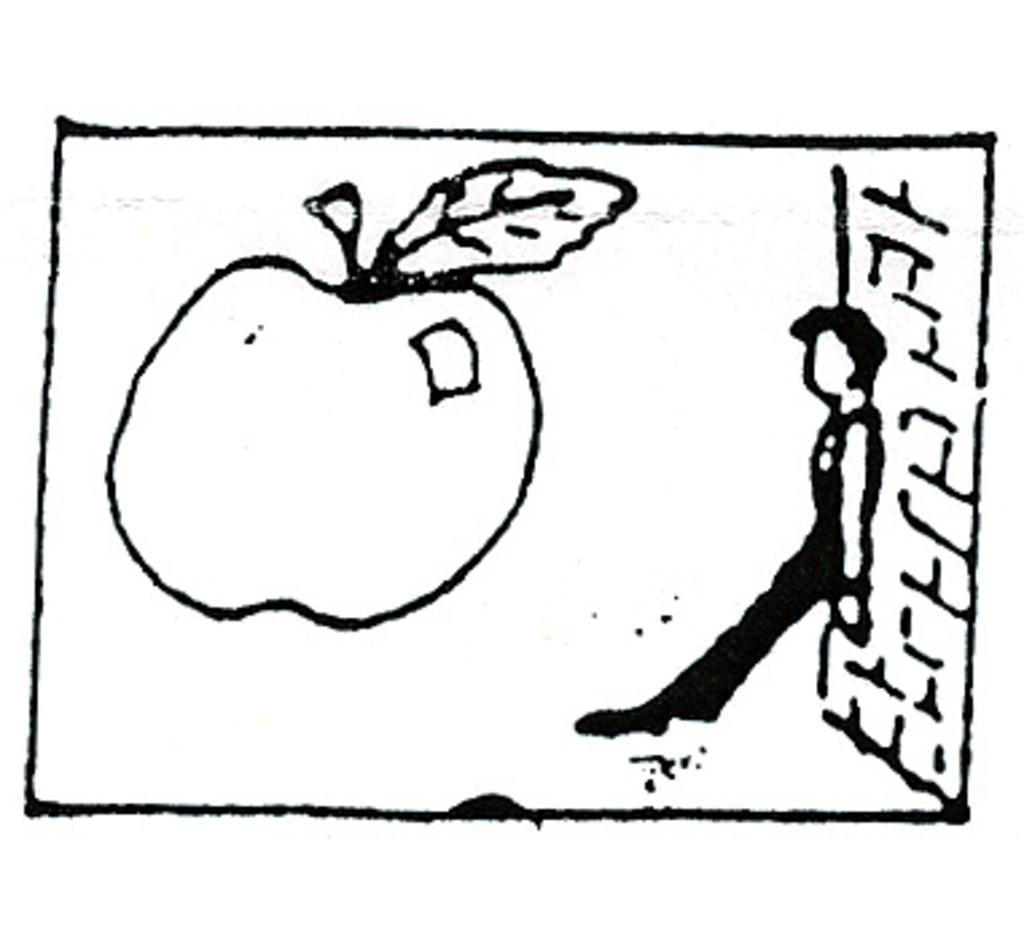What is depicted on the left side of the image? There is a sketch of an apple on the left side of the image. What is the person on the right side of the image doing? The person is leaning against a wall on the right side of the image. What type of produce is being skated on in the image? There is no produce or skating activity present in the image. How is the wire being used in the image? There is no wire present in the image. 